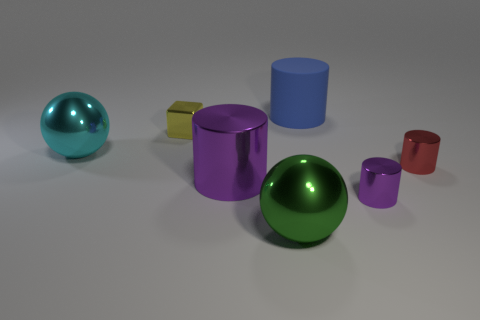Add 2 blue cylinders. How many objects exist? 9 Subtract all balls. How many objects are left? 5 Add 3 red metallic objects. How many red metallic objects are left? 4 Add 6 big gray matte cylinders. How many big gray matte cylinders exist? 6 Subtract 1 cyan balls. How many objects are left? 6 Subtract all large red cylinders. Subtract all tiny purple metallic cylinders. How many objects are left? 6 